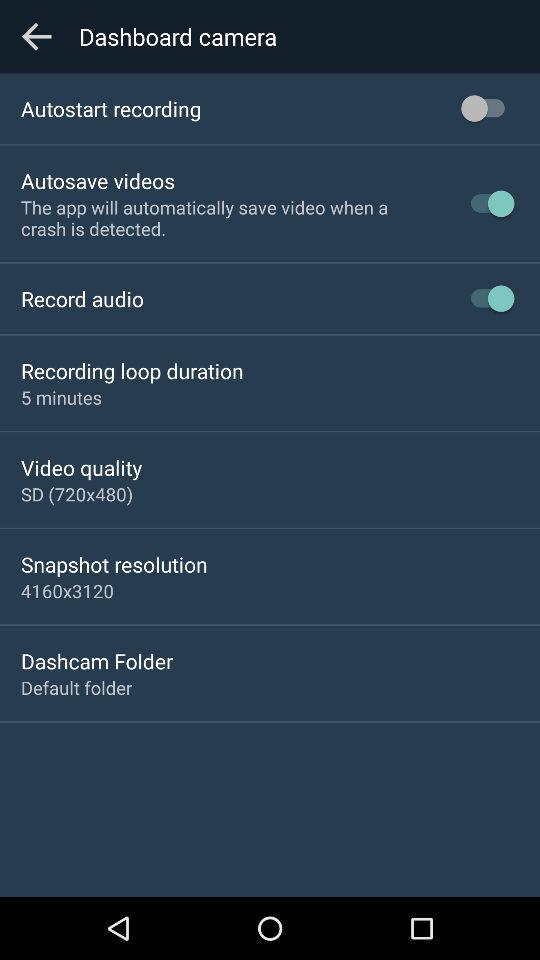What is the status of "Record audio"? The status is "on". 